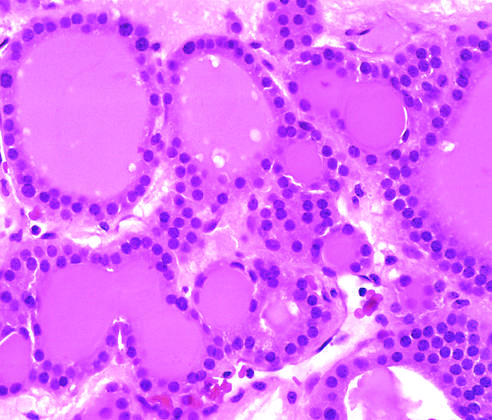s genomic dna visible in this gross specimen?
Answer the question using a single word or phrase. No 